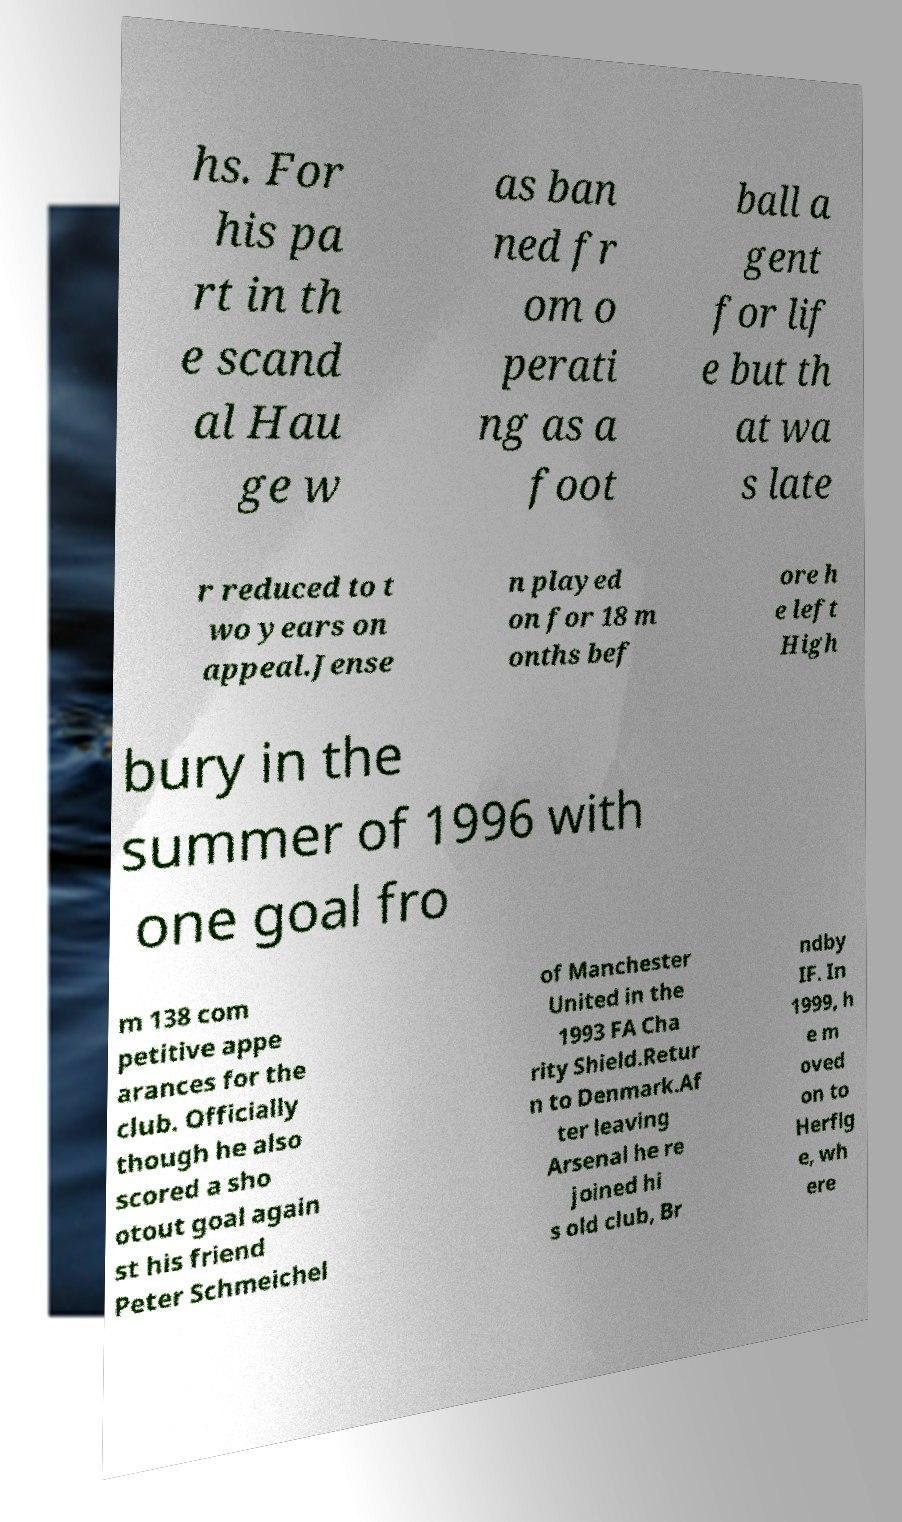Can you provide more details about the 1993 FA Charity Shield event mentioned in the text? The 1993 FA Charity Shield was a football match between Arsenal FC and Manchester United, which ended in a draw. The text mentions that Jensen scored against Peter Schmeichel during a shootout in this event, adding a notable highlight to his career despite a generally low scoring record at Arsenal. 